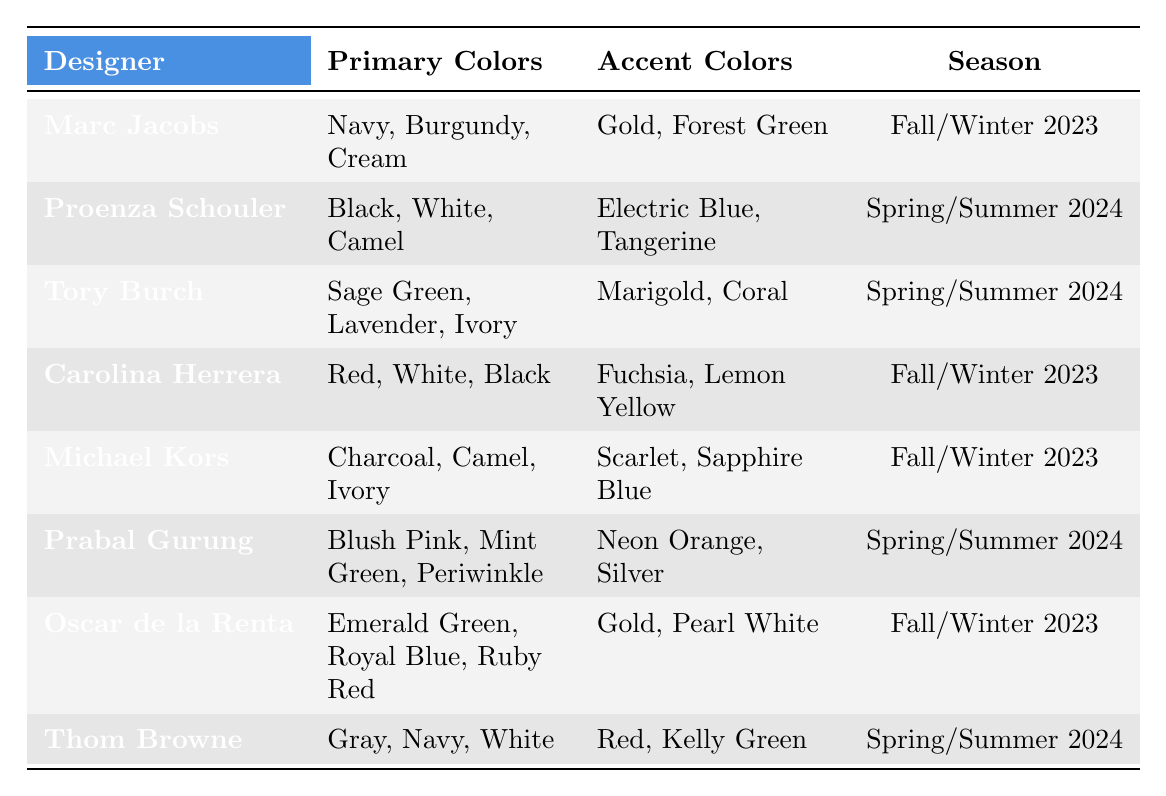What colors does Marc Jacobs use in his collection? Referring to the table, Marc Jacobs' primary colors are Navy, Burgundy, and Cream, while his accent colors are Gold and Forest Green.
Answer: Navy, Burgundy, Cream; Gold, Forest Green Which designers have collections for Spring/Summer 2024? The table lists Proenza Schouler, Tory Burch, Prabal Gurung, and Thom Browne as the designers with collections for Spring/Summer 2024.
Answer: Proenza Schouler, Tory Burch, Prabal Gurung, Thom Browne Is Oscar de la Renta's collection for Fall/Winter 2023? According to the table, Oscar de la Renta's collection is indeed labeled under the Fall/Winter 2023 season.
Answer: Yes What is the most common primary color among designers in the Spring/Summer 2024 collections? In the table, the primary colors for Spring/Summer 2024 are Black, White, Camel, Sage Green, Lavender, Ivory, Blush Pink, Mint Green, and Periwinkle. There are no repeated primary colors, so no color is most common.
Answer: None How many total primary colors are listed for Carolina Herrera and Michael Kors combined? Carolina Herrera uses Red, White, and Black—3 primary colors. Michael Kors uses Charcoal, Camel, and Ivory—also 3 primary colors. Adding these together gives 3 + 3 = 6.
Answer: 6 Which designer has the accent color Neon Orange? The table shows that Prabal Gurung has Neon Orange as one of the accent colors in his Spring/Summer 2024 collection.
Answer: Prabal Gurung Are there any collections that feature the color Coral? The table shows that Tory Burch has Coral as one of the accent colors in her Spring/Summer 2024 collection.
Answer: Yes Which collection features the highest number of accent colors? Evaluating the accent colors listed for each designer, each collection generally has 2 accent colors. Hence, there are no collections with a higher count than others in terms of accent colors.
Answer: None Which season has more collections listed, Fall/Winter 2023 or Spring/Summer 2024? The table shows 4 collections listed for Fall/Winter 2023 and 4 collections for Spring/Summer 2024. This means they have an equal number of collections.
Answer: Equal What are the primary colors for Michael Kors? Referring to the table, Michael Kors uses Charcoal, Camel, and Ivory as his primary colors.
Answer: Charcoal, Camel, Ivory 